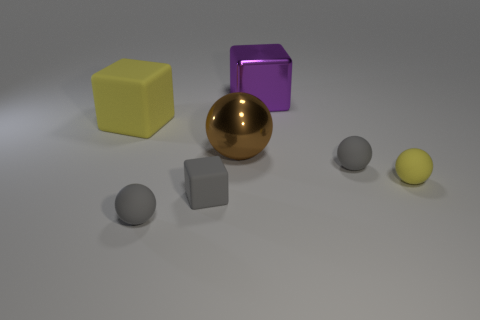Is there another shiny block that has the same color as the metallic block?
Your response must be concise. No. Are there an equal number of tiny yellow rubber spheres that are in front of the yellow cube and large purple metal spheres?
Provide a short and direct response. No. What number of gray matte things are there?
Offer a terse response. 3. There is a large thing that is both on the right side of the yellow cube and in front of the big purple shiny thing; what is its shape?
Your response must be concise. Sphere. There is a large cube left of the purple cube; does it have the same color as the tiny rubber ball that is left of the large purple shiny object?
Offer a terse response. No. What size is the object that is the same color as the large rubber cube?
Offer a very short reply. Small. Are there any yellow things made of the same material as the brown sphere?
Ensure brevity in your answer.  No. Are there an equal number of things left of the purple metallic cube and big metal spheres to the left of the big brown metal sphere?
Offer a very short reply. No. There is a yellow object to the right of the small gray block; what is its size?
Keep it short and to the point. Small. The gray thing to the right of the large purple object that is behind the large yellow object is made of what material?
Offer a very short reply. Rubber. 